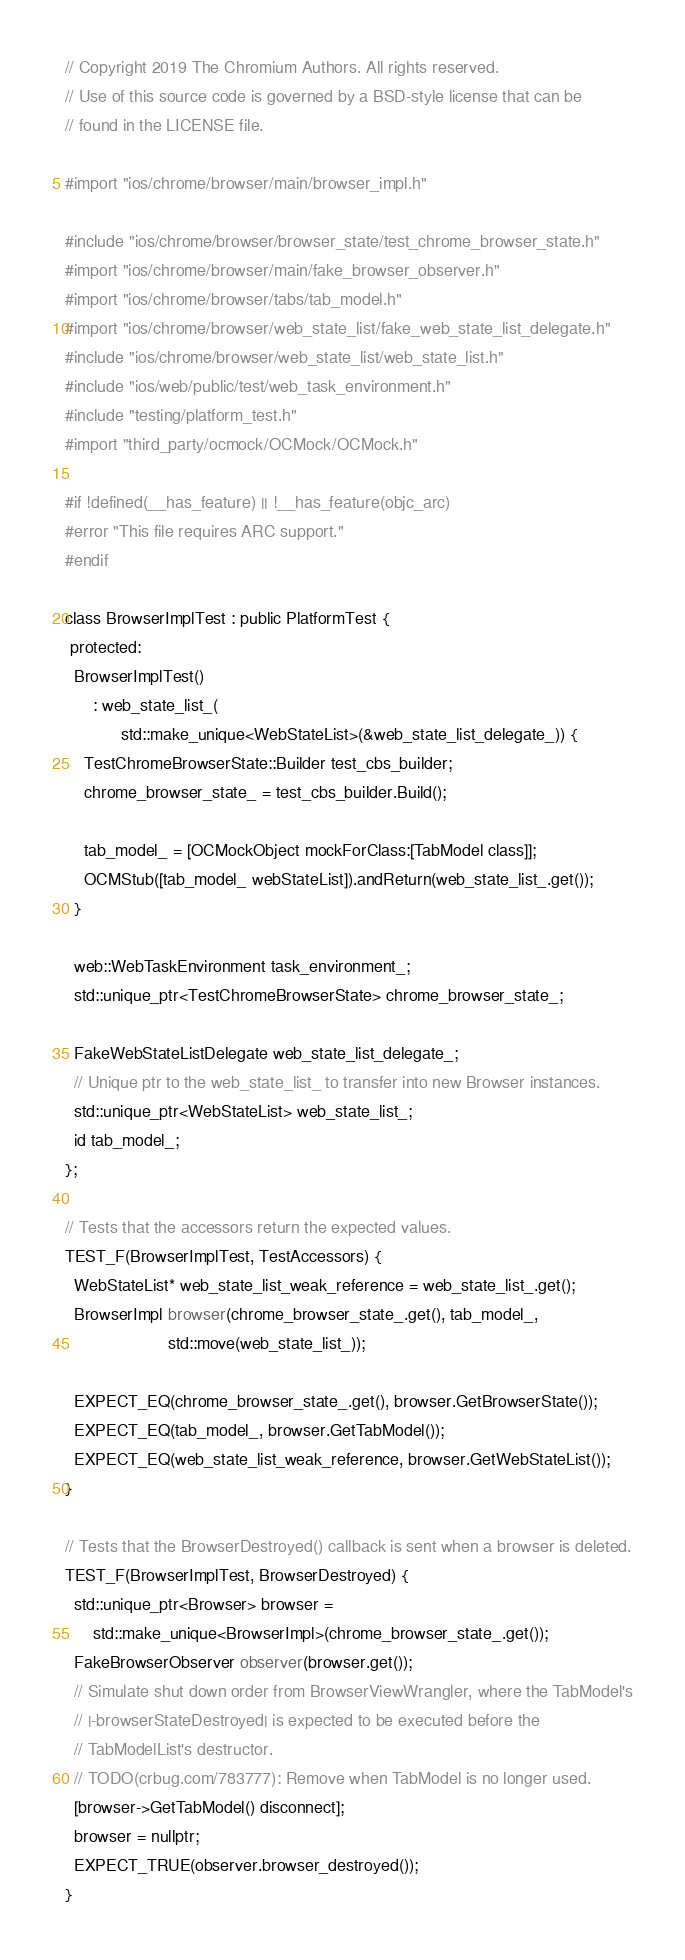<code> <loc_0><loc_0><loc_500><loc_500><_ObjectiveC_>// Copyright 2019 The Chromium Authors. All rights reserved.
// Use of this source code is governed by a BSD-style license that can be
// found in the LICENSE file.

#import "ios/chrome/browser/main/browser_impl.h"

#include "ios/chrome/browser/browser_state/test_chrome_browser_state.h"
#import "ios/chrome/browser/main/fake_browser_observer.h"
#import "ios/chrome/browser/tabs/tab_model.h"
#import "ios/chrome/browser/web_state_list/fake_web_state_list_delegate.h"
#include "ios/chrome/browser/web_state_list/web_state_list.h"
#include "ios/web/public/test/web_task_environment.h"
#include "testing/platform_test.h"
#import "third_party/ocmock/OCMock/OCMock.h"

#if !defined(__has_feature) || !__has_feature(objc_arc)
#error "This file requires ARC support."
#endif

class BrowserImplTest : public PlatformTest {
 protected:
  BrowserImplTest()
      : web_state_list_(
            std::make_unique<WebStateList>(&web_state_list_delegate_)) {
    TestChromeBrowserState::Builder test_cbs_builder;
    chrome_browser_state_ = test_cbs_builder.Build();

    tab_model_ = [OCMockObject mockForClass:[TabModel class]];
    OCMStub([tab_model_ webStateList]).andReturn(web_state_list_.get());
  }

  web::WebTaskEnvironment task_environment_;
  std::unique_ptr<TestChromeBrowserState> chrome_browser_state_;

  FakeWebStateListDelegate web_state_list_delegate_;
  // Unique ptr to the web_state_list_ to transfer into new Browser instances.
  std::unique_ptr<WebStateList> web_state_list_;
  id tab_model_;
};

// Tests that the accessors return the expected values.
TEST_F(BrowserImplTest, TestAccessors) {
  WebStateList* web_state_list_weak_reference = web_state_list_.get();
  BrowserImpl browser(chrome_browser_state_.get(), tab_model_,
                      std::move(web_state_list_));

  EXPECT_EQ(chrome_browser_state_.get(), browser.GetBrowserState());
  EXPECT_EQ(tab_model_, browser.GetTabModel());
  EXPECT_EQ(web_state_list_weak_reference, browser.GetWebStateList());
}

// Tests that the BrowserDestroyed() callback is sent when a browser is deleted.
TEST_F(BrowserImplTest, BrowserDestroyed) {
  std::unique_ptr<Browser> browser =
      std::make_unique<BrowserImpl>(chrome_browser_state_.get());
  FakeBrowserObserver observer(browser.get());
  // Simulate shut down order from BrowserViewWrangler, where the TabModel's
  // |-browserStateDestroyed| is expected to be executed before the
  // TabModelList's destructor.
  // TODO(crbug.com/783777): Remove when TabModel is no longer used.
  [browser->GetTabModel() disconnect];
  browser = nullptr;
  EXPECT_TRUE(observer.browser_destroyed());
}
</code> 